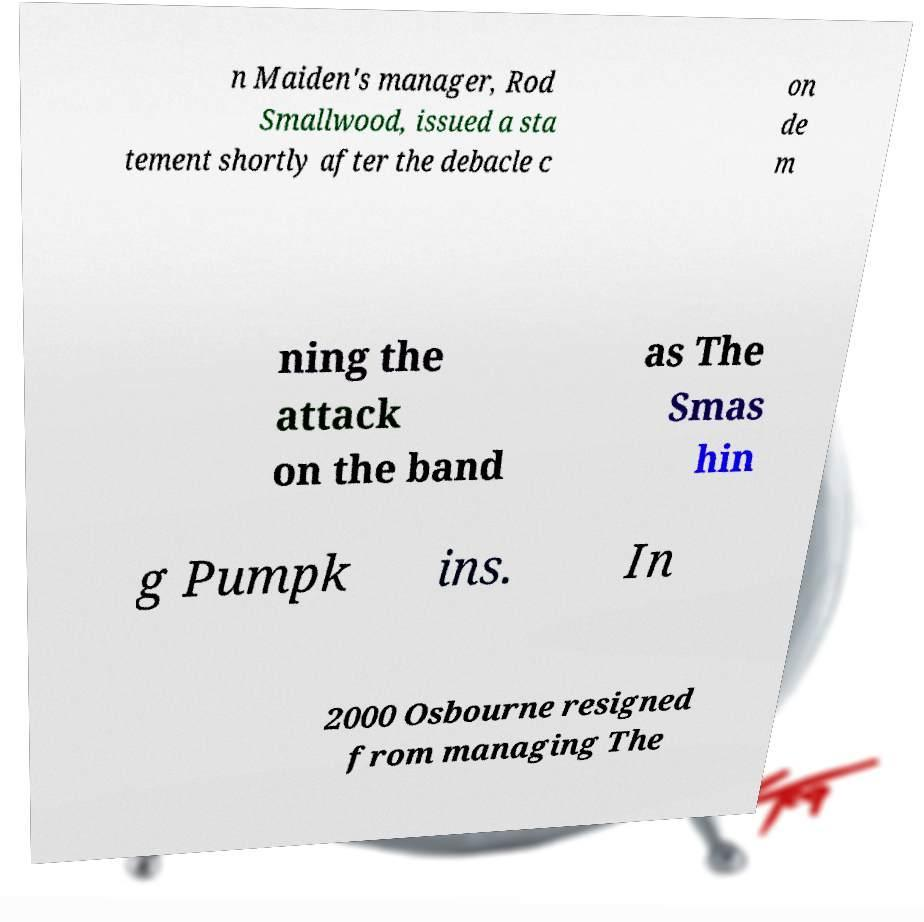I need the written content from this picture converted into text. Can you do that? n Maiden's manager, Rod Smallwood, issued a sta tement shortly after the debacle c on de m ning the attack on the band as The Smas hin g Pumpk ins. In 2000 Osbourne resigned from managing The 